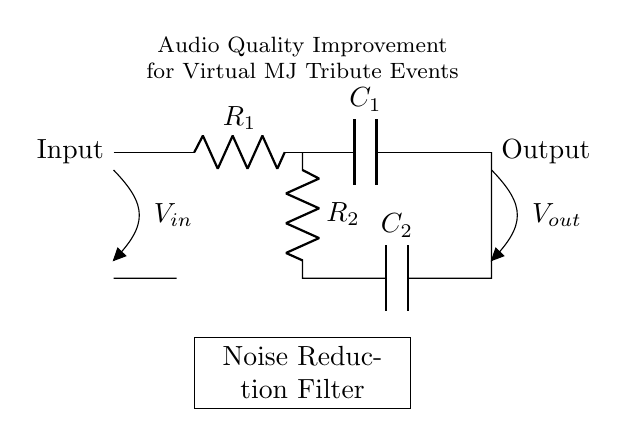What is the input of this circuit? The input is labeled as V_in, which indicates the voltage input provided to the circuit for processing.
Answer: V_in What is the output of this circuit? The output is labeled as V_out, representing the processed audio output after passing through the noise reduction filter.
Answer: V_out How many resistors are present in the circuit? There are two resistors shown, R_1 and R_2, indicating that the circuit includes two resistance components.
Answer: 2 What type of components are R_1 and R_2? Both R_1 and R_2 are resistors, which are essential components used to manage current flow and voltage in the circuit.
Answer: Resistors What kind of filter does this circuit represent? The circuit is explicitly labeled as a Noise Reduction Filter, which implies it is designed to minimize unwanted noise in audio signals.
Answer: Noise Reduction Filter How does C_1 contribute to the circuit? Capacitor C_1 helps in filtering high-frequency noise by providing an alternate path for high-frequency components, effectively smoothing the output audio quality.
Answer: Filtering high-frequency noise What is the primary purpose of this circuit in the context provided? The primary purpose of the circuit, as indicated, is to improve audio quality during virtual Michael Jackson tribute events by reducing noise interference.
Answer: Improve audio quality 